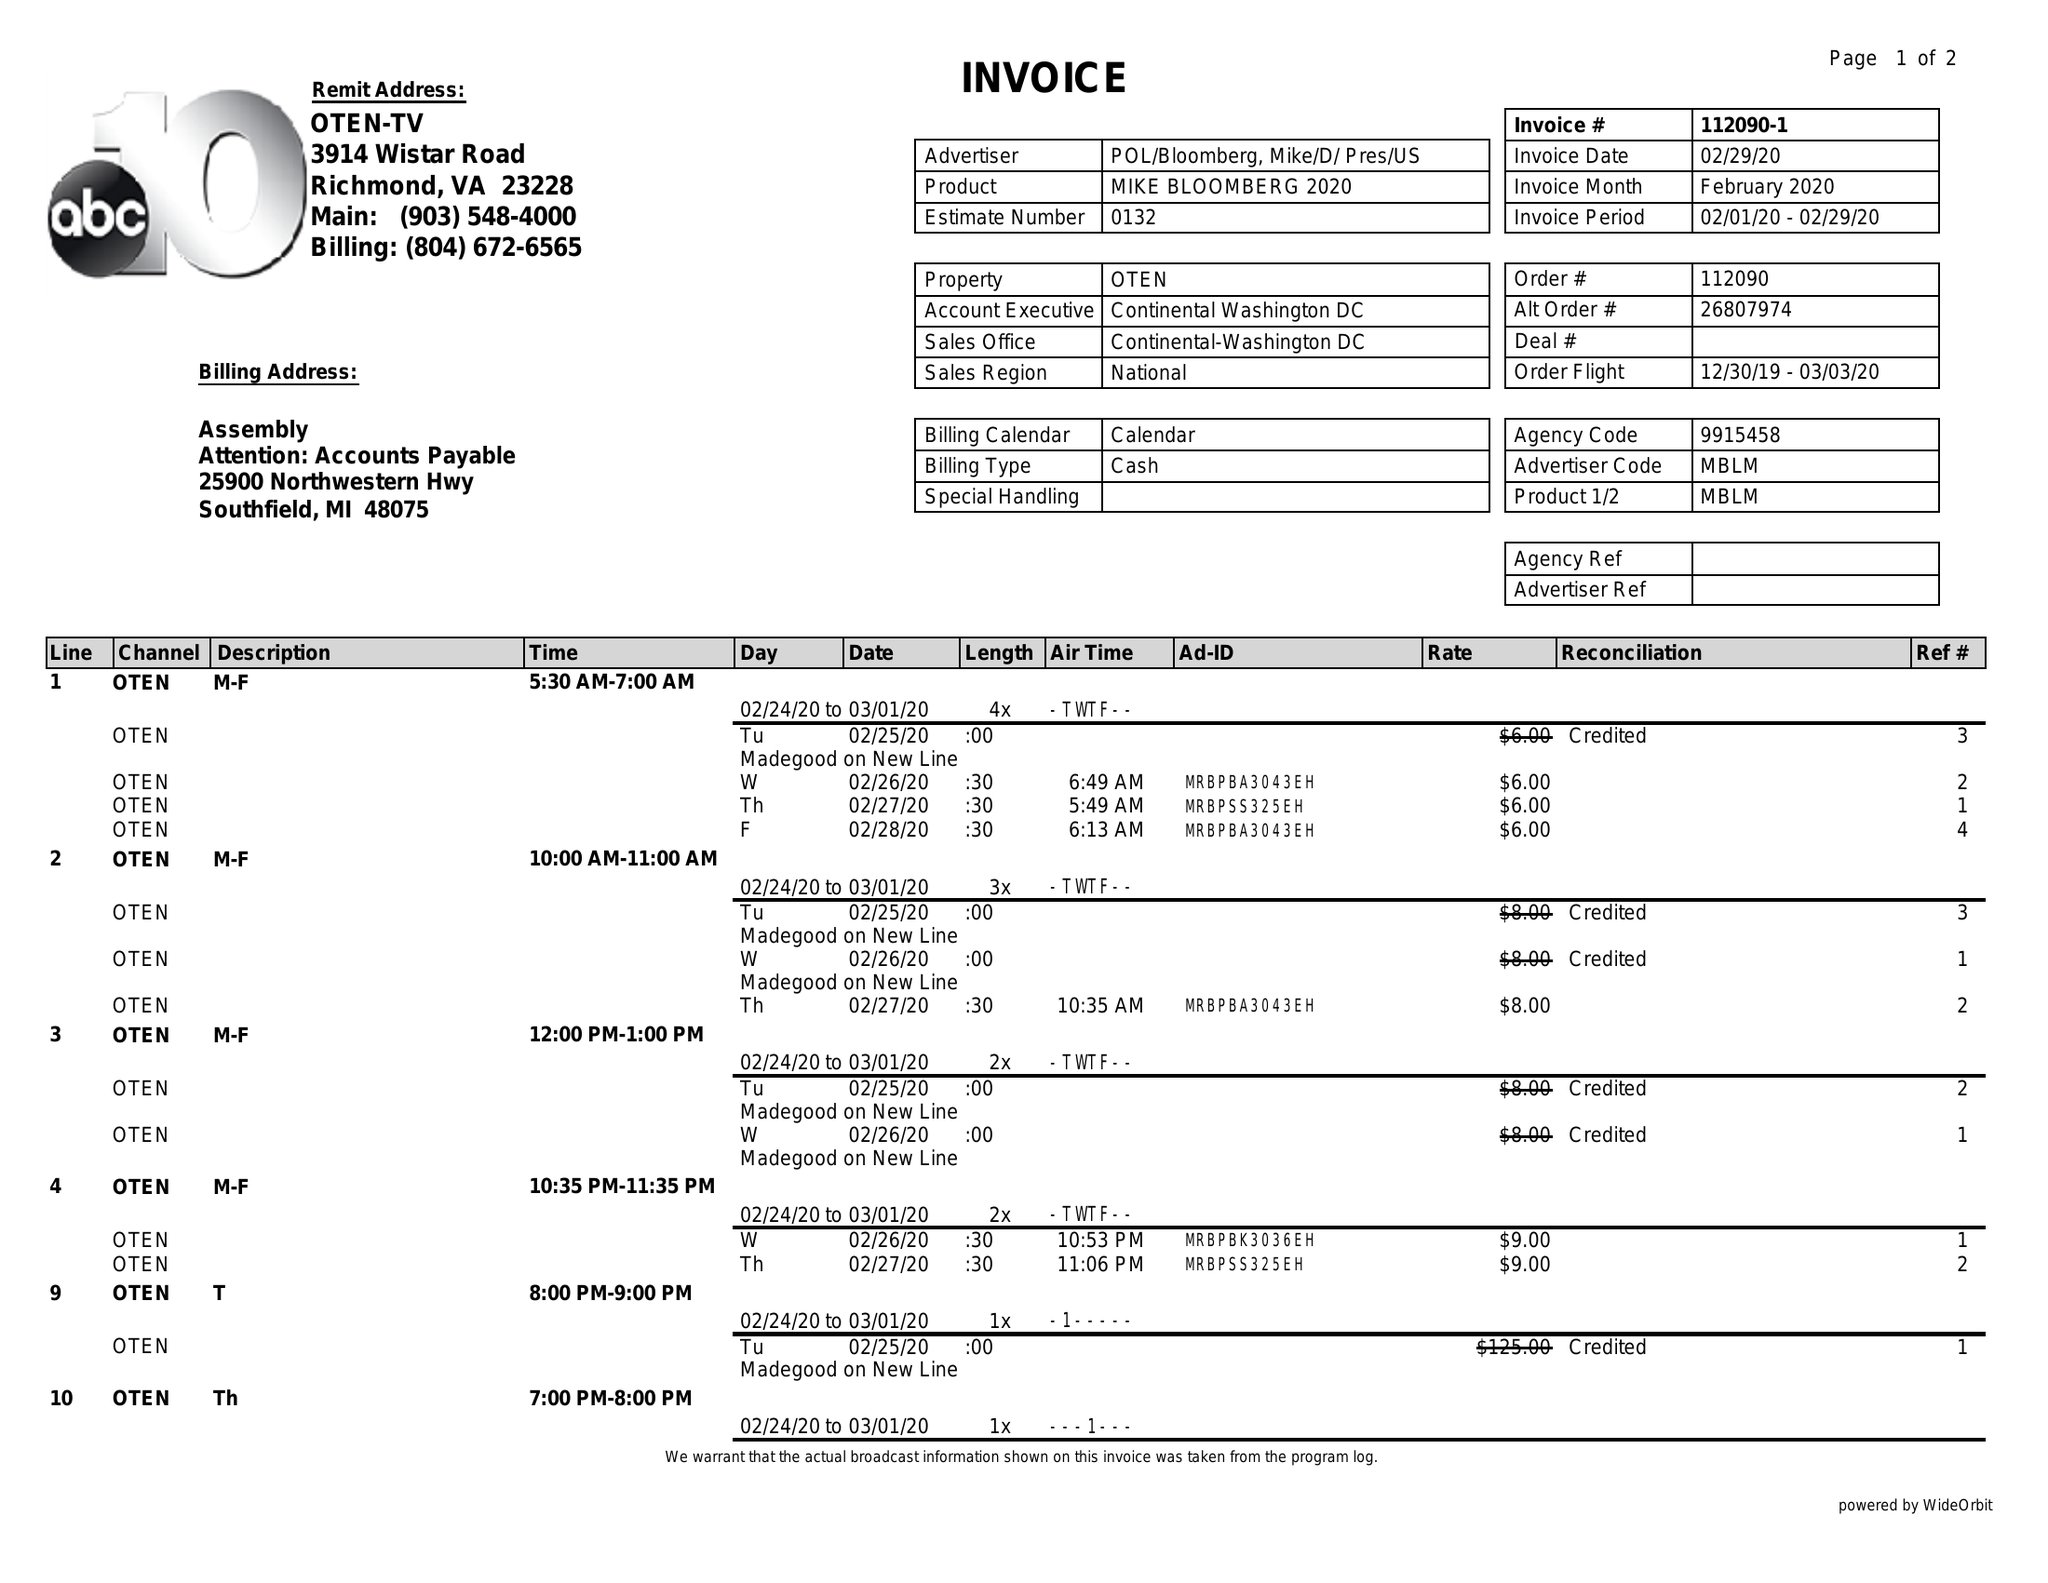What is the value for the flight_to?
Answer the question using a single word or phrase. 03/03/20 